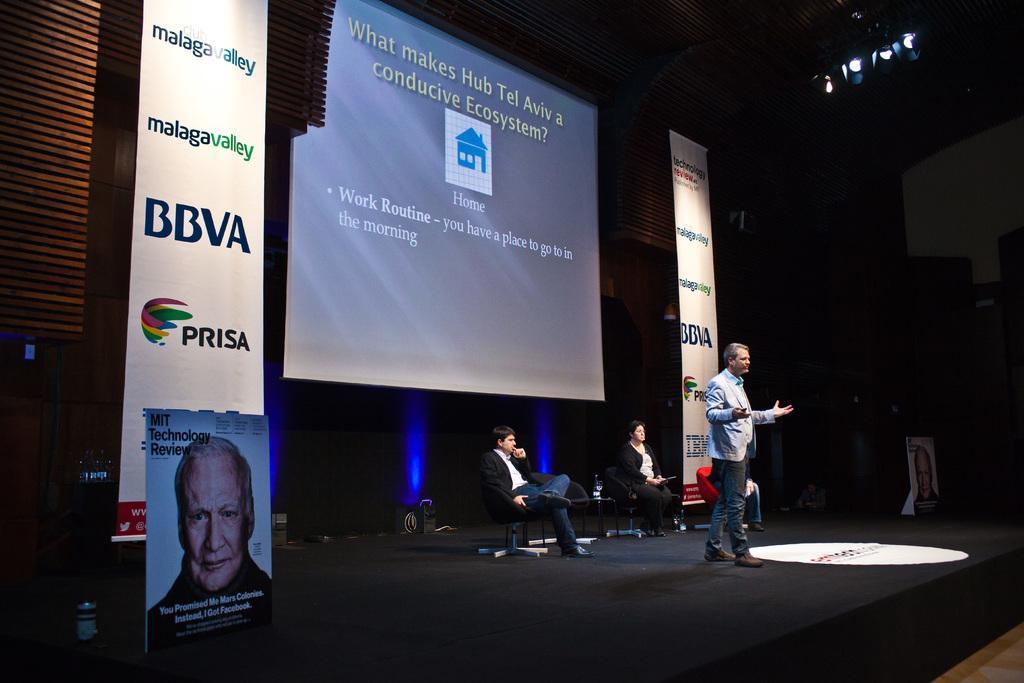Could you give a brief overview of what you see in this image? The picture is taken during a conference. In the center of the picture there is a person on the stage. In the center of the picture there are chairs and people sitting in them. In the background there is a screen. On the left there are hoardings. On the right there are hoardings and lights. 